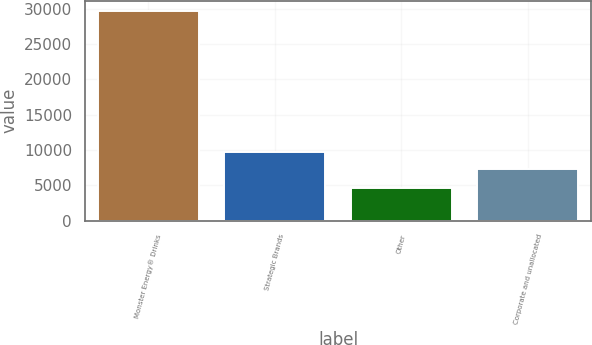Convert chart. <chart><loc_0><loc_0><loc_500><loc_500><bar_chart><fcel>Monster Energy® Drinks<fcel>Strategic Brands<fcel>Other<fcel>Corporate and unallocated<nl><fcel>29591<fcel>9743.3<fcel>4608<fcel>7245<nl></chart> 